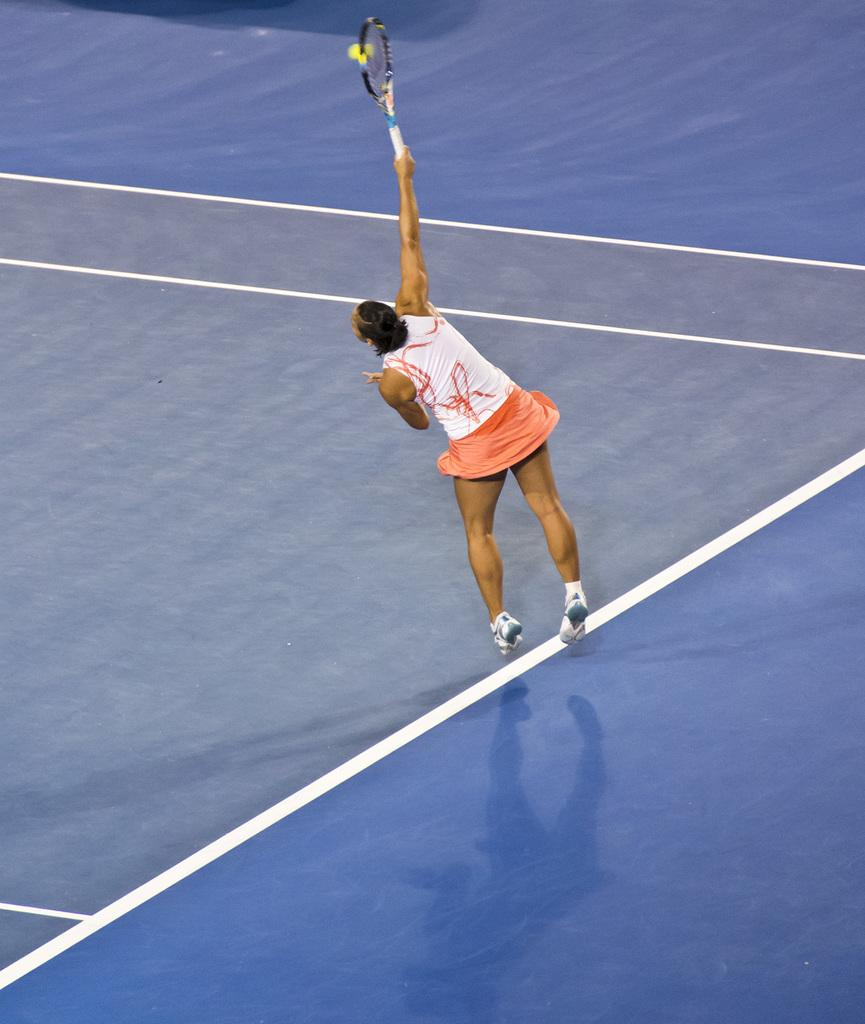What type of location is shown in the image? The image is taken in a tennis court. What can be seen under the woman's feet in the image? There is a floor visible in the image. What is the woman doing in the image? The woman is playing tennis in the image. What equipment is the woman using to play tennis? The woman is using a tennis bat in the image. What object is being hit by the tennis bat in the image? A tennis ball is present in the image. What type of flowers can be seen growing on the tennis court in the image? There are no flowers visible in the image; it is a tennis court with a floor and a woman playing tennis with a tennis bat and a tennis ball. 